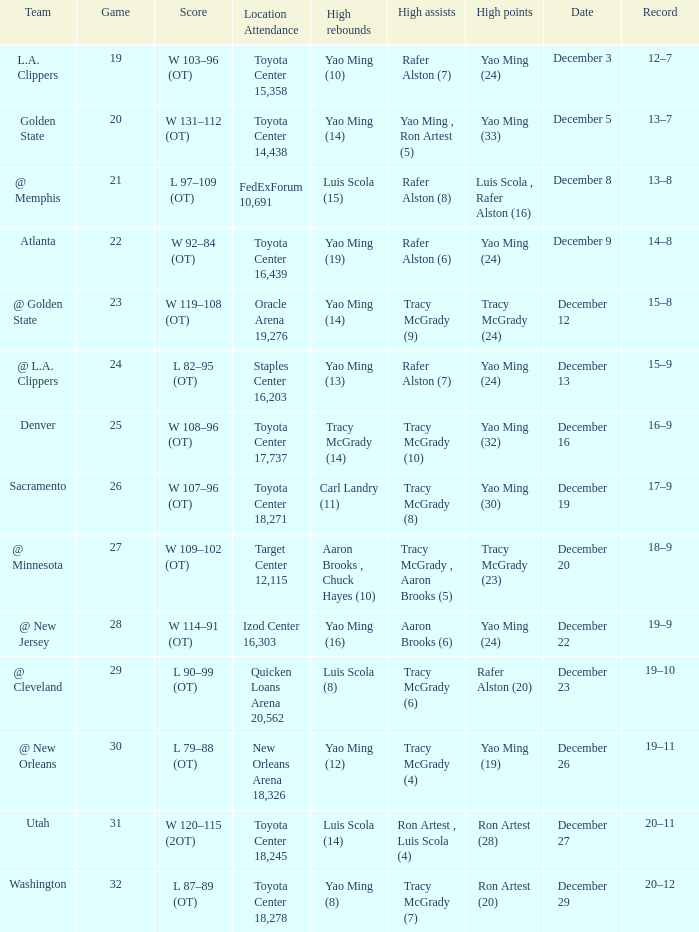When @ new orleans is the team who has the highest amount of rebounds? Yao Ming (12). 